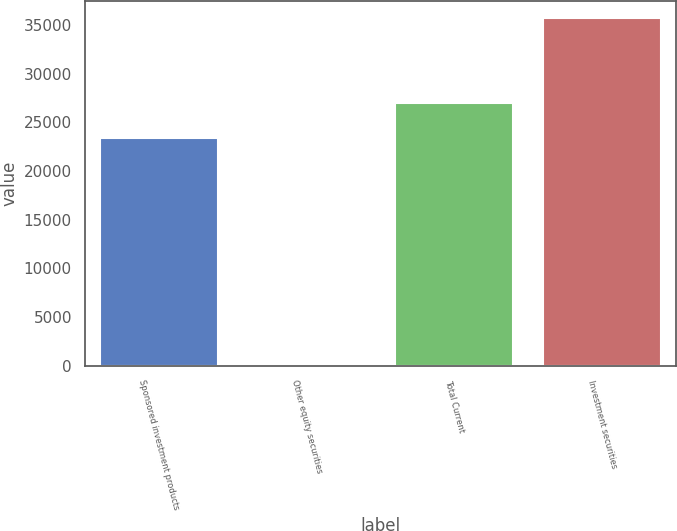<chart> <loc_0><loc_0><loc_500><loc_500><bar_chart><fcel>Sponsored investment products<fcel>Other equity securities<fcel>Total Current<fcel>Investment securities<nl><fcel>23394<fcel>26<fcel>26962.7<fcel>35713<nl></chart> 